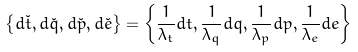<formula> <loc_0><loc_0><loc_500><loc_500>\left \{ d \check { t } , d \check { q } , d \check { p } , d \check { e } \right \} = \left \{ \frac { 1 } { \lambda _ { t } } d t , \frac { 1 } { \lambda _ { q } } d q , \frac { 1 } { \lambda _ { p } } d p , \frac { 1 } { \lambda _ { e } } d e \right \}</formula> 